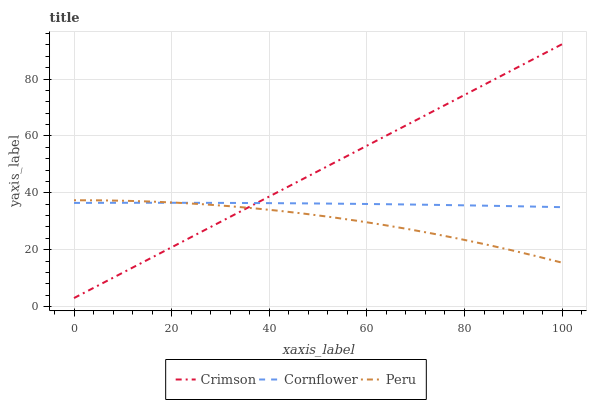Does Peru have the minimum area under the curve?
Answer yes or no. Yes. Does Crimson have the maximum area under the curve?
Answer yes or no. Yes. Does Cornflower have the minimum area under the curve?
Answer yes or no. No. Does Cornflower have the maximum area under the curve?
Answer yes or no. No. Is Crimson the smoothest?
Answer yes or no. Yes. Is Peru the roughest?
Answer yes or no. Yes. Is Cornflower the smoothest?
Answer yes or no. No. Is Cornflower the roughest?
Answer yes or no. No. Does Peru have the lowest value?
Answer yes or no. No. Does Crimson have the highest value?
Answer yes or no. Yes. Does Peru have the highest value?
Answer yes or no. No. Does Cornflower intersect Crimson?
Answer yes or no. Yes. Is Cornflower less than Crimson?
Answer yes or no. No. Is Cornflower greater than Crimson?
Answer yes or no. No. 